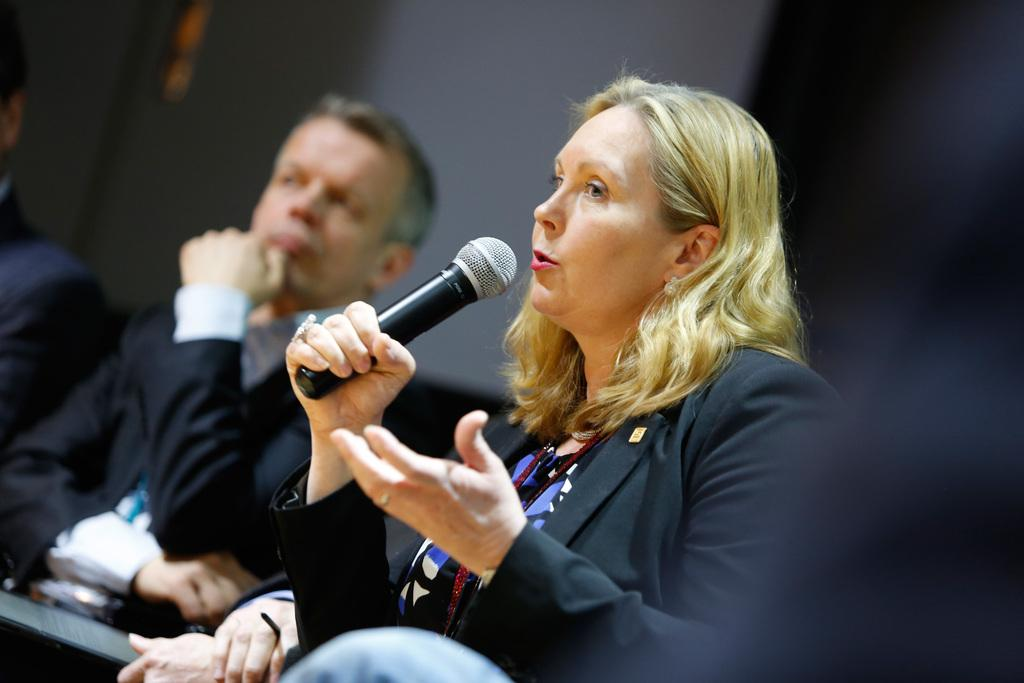What is the woman in the image doing? The woman is talking into a microphone. What is the woman wearing in the image? The woman is wearing a black coat. Who else is present in the image? There is a man in the image. What is the man wearing in the image? The man is wearing a black coat. What type of coal is being used by the goose in the image? There is no goose or coal present in the image. What riddle is the woman trying to solve in the image? There is no riddle mentioned or depicted in the image. 